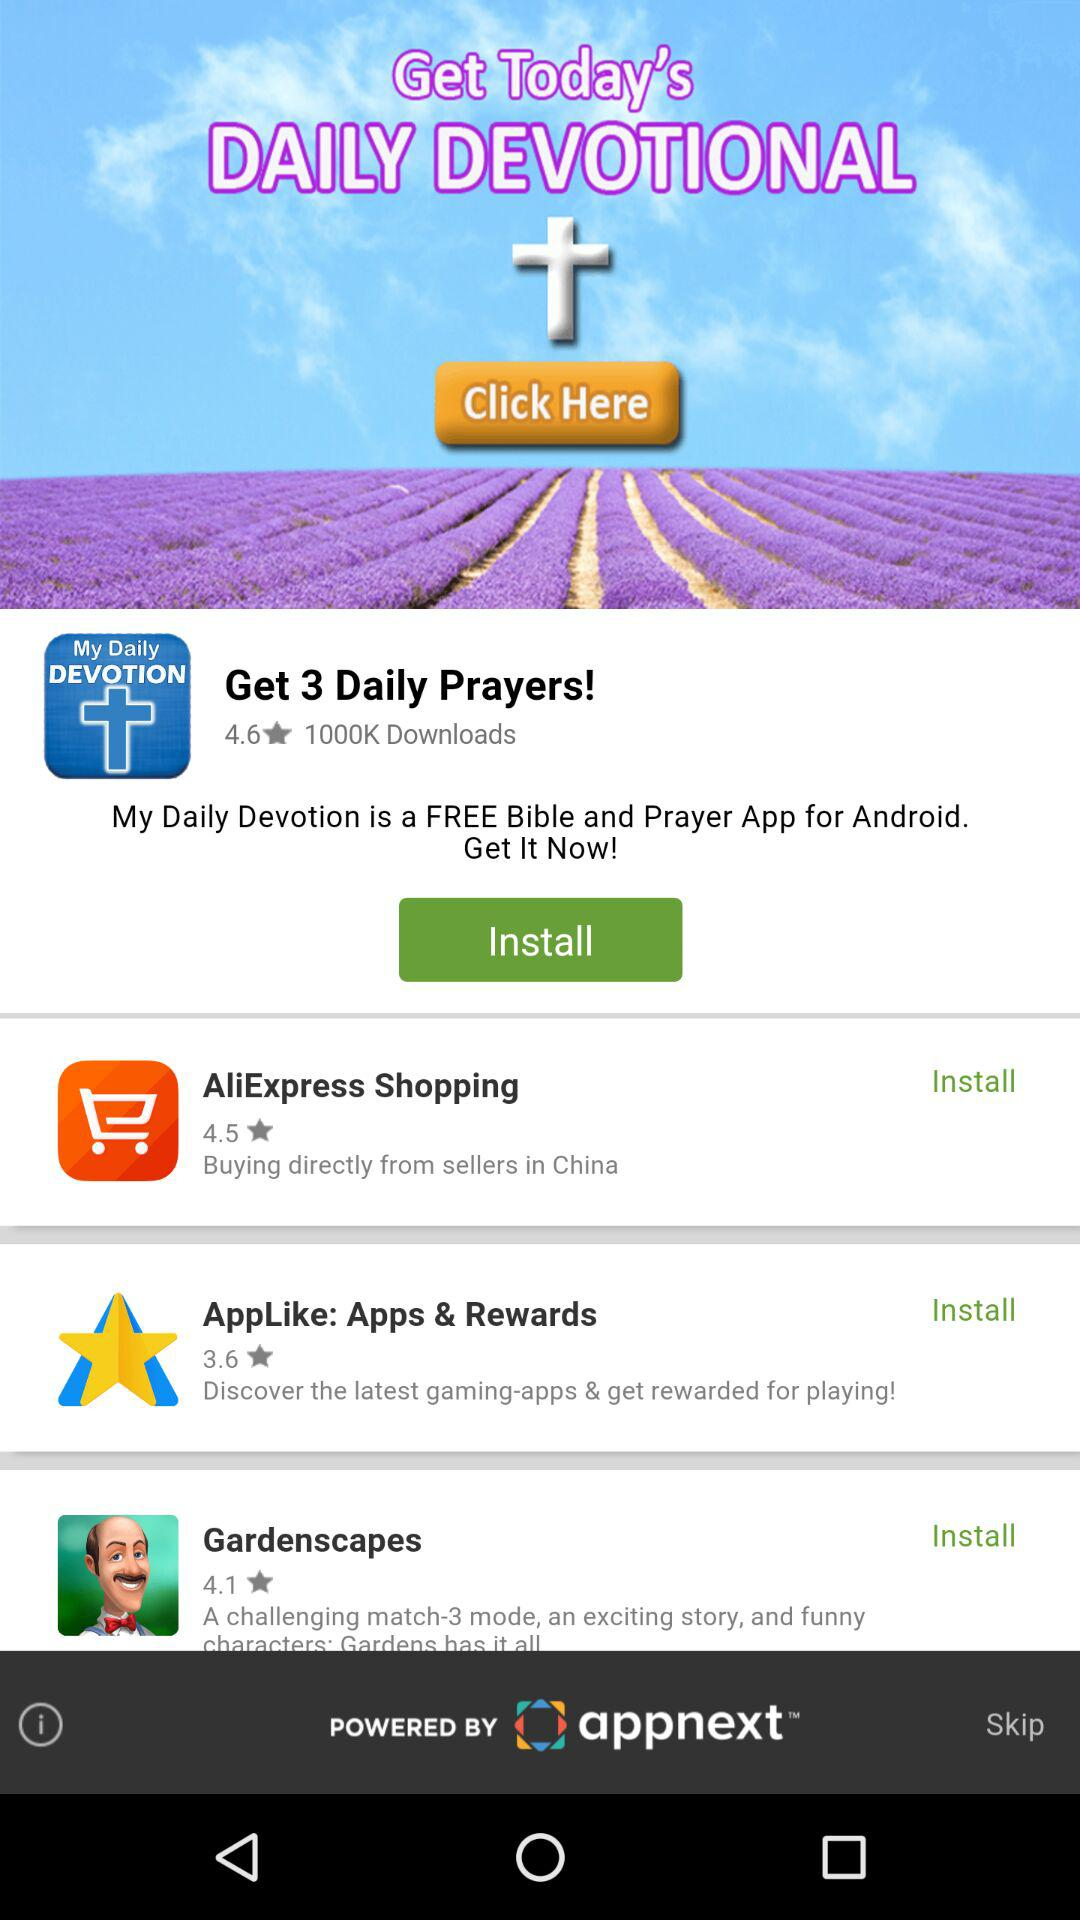How many apps have a rating of 4.5 or higher?
Answer the question using a single word or phrase. 2 